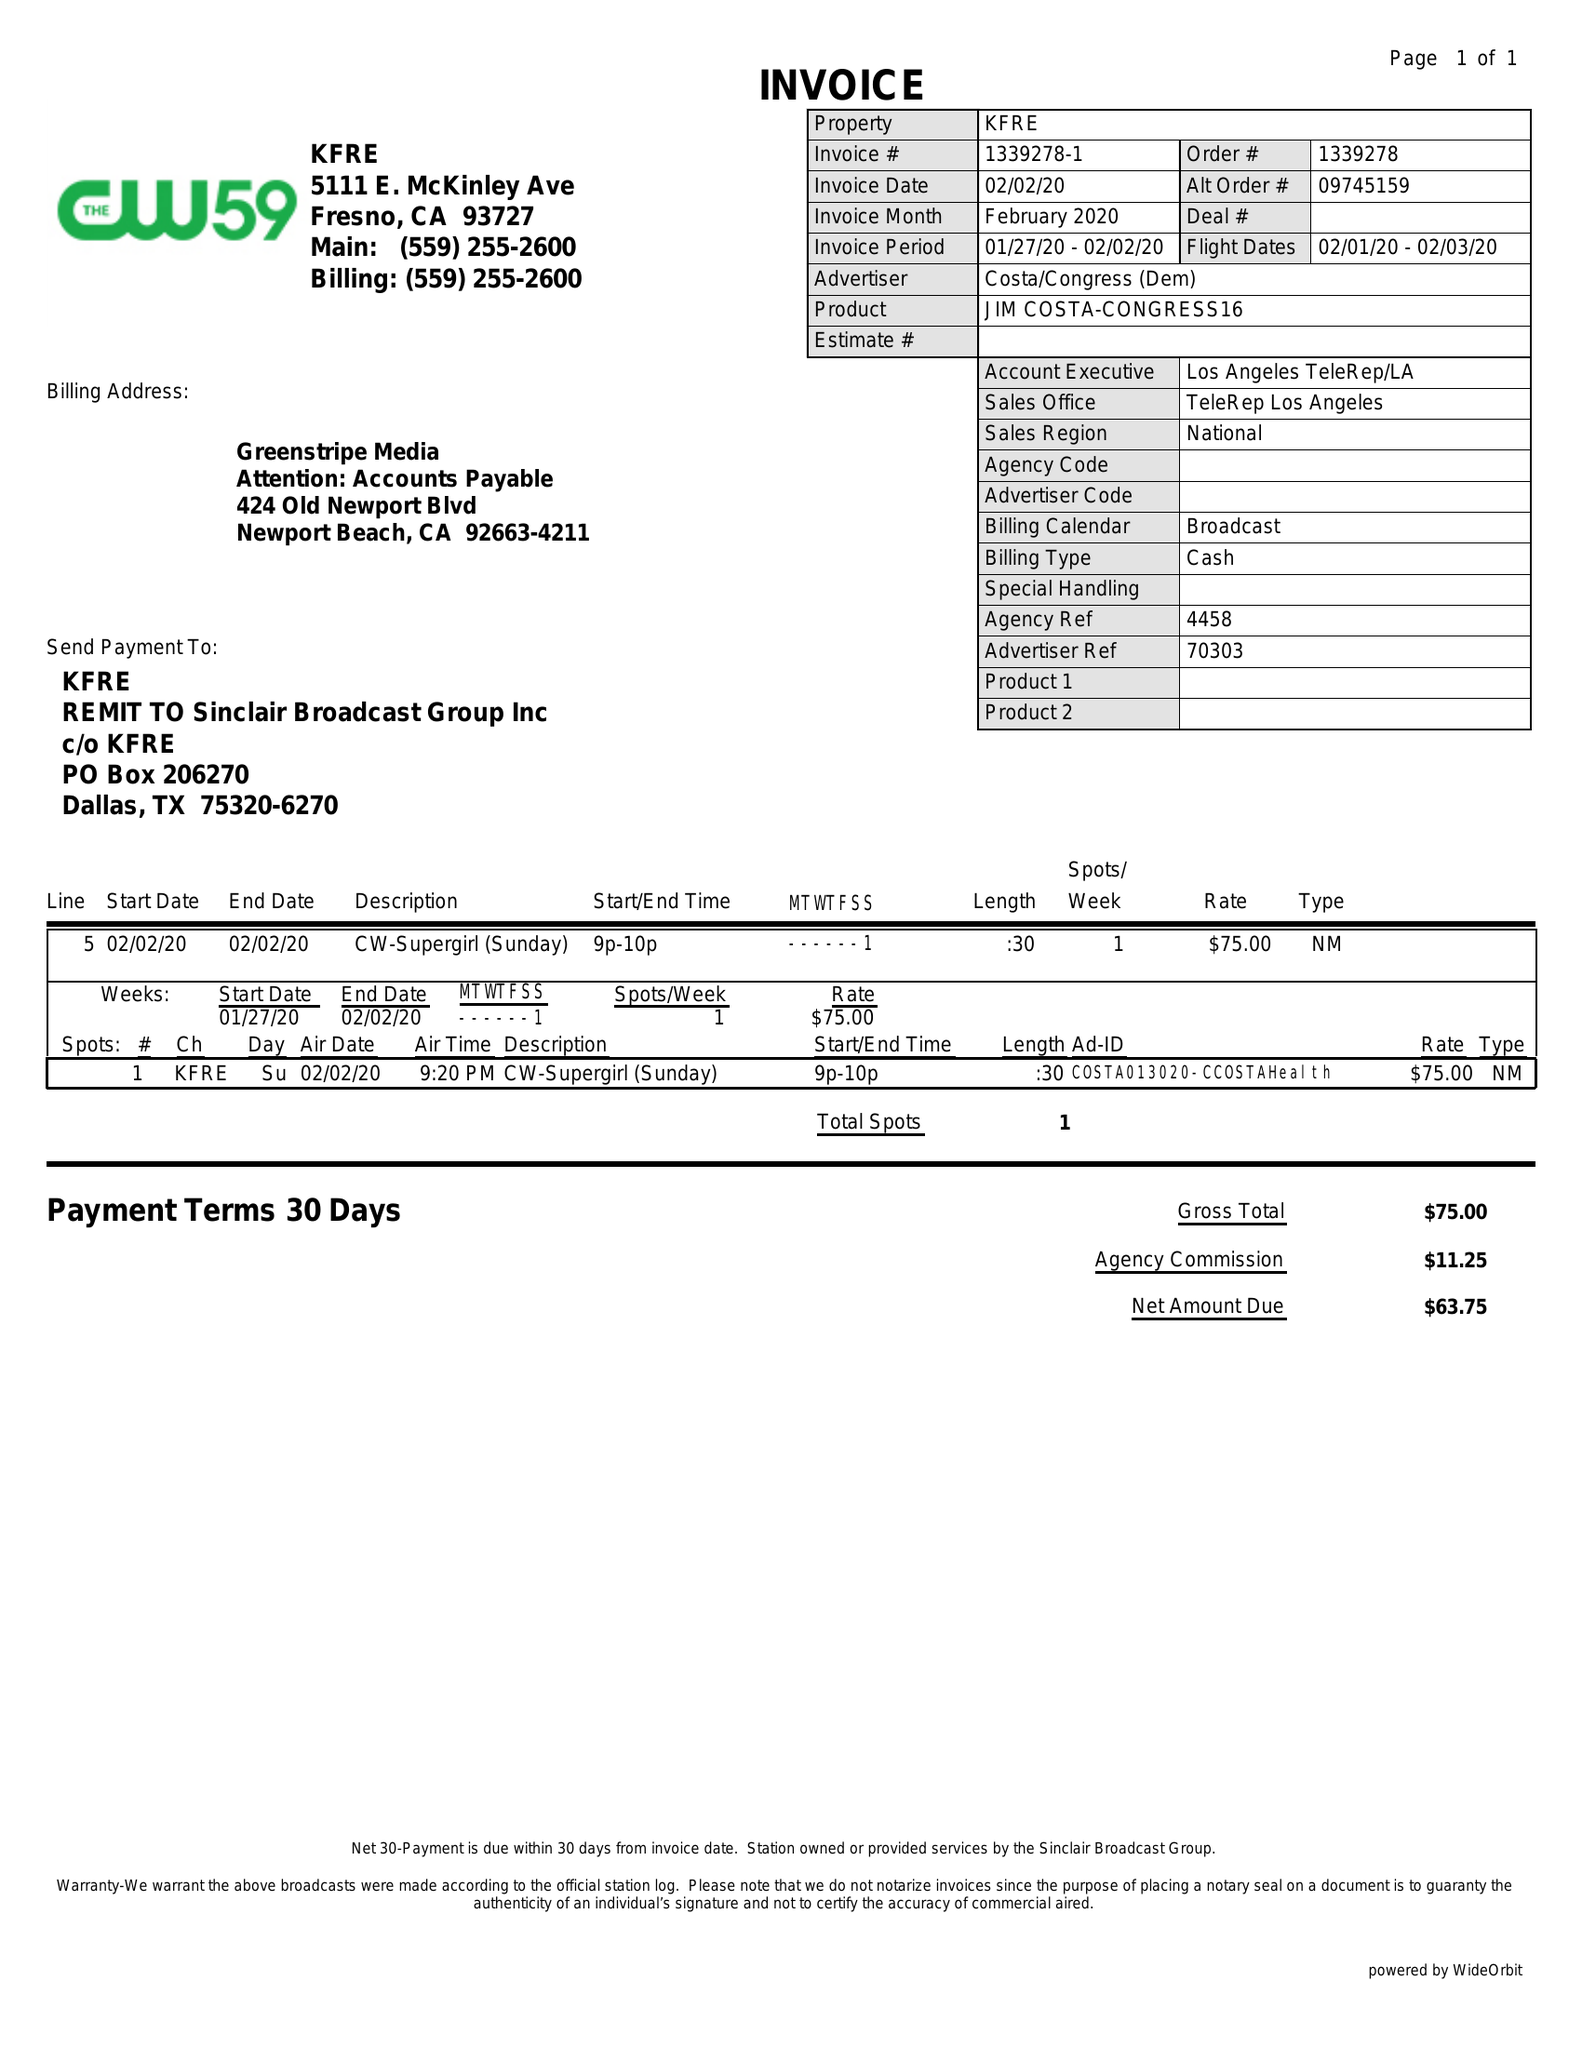What is the value for the gross_amount?
Answer the question using a single word or phrase. 75.00 